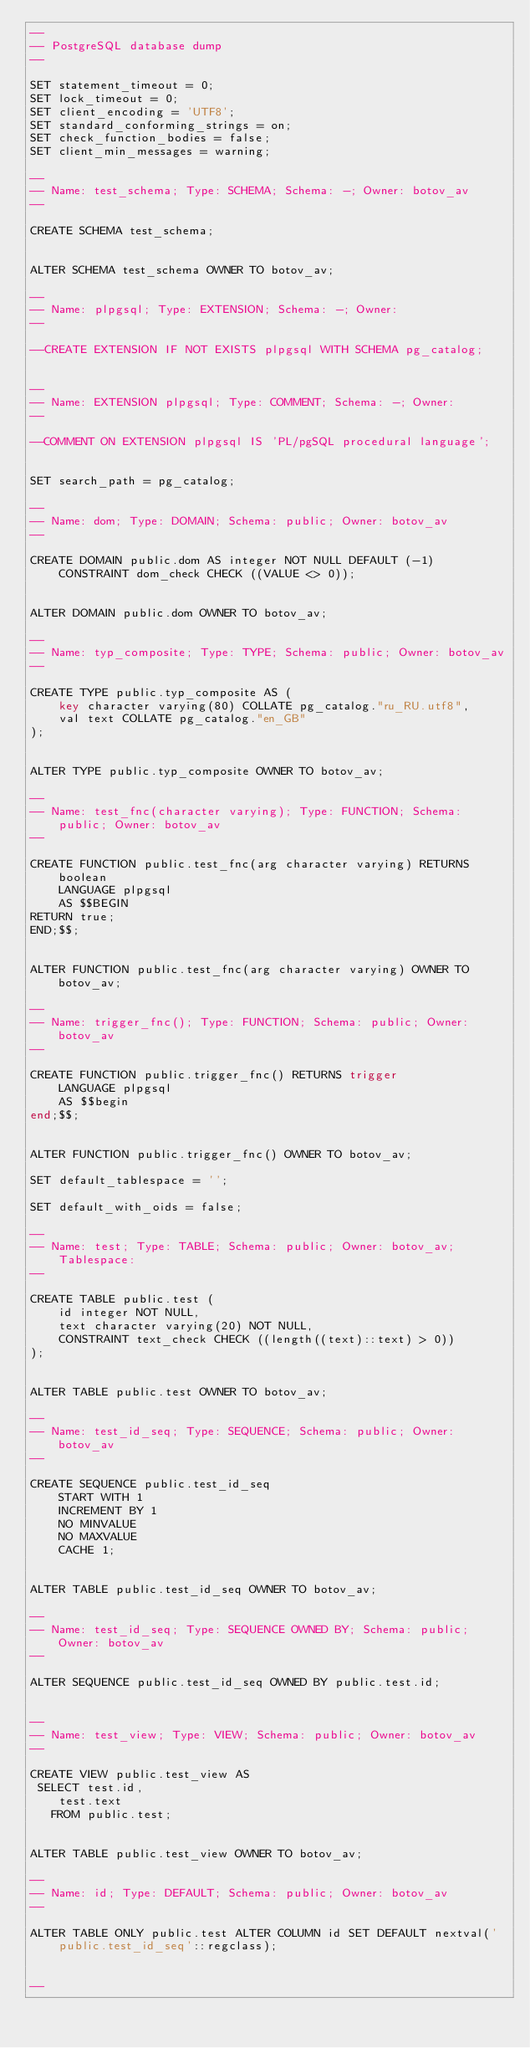Convert code to text. <code><loc_0><loc_0><loc_500><loc_500><_SQL_>--
-- PostgreSQL database dump
--

SET statement_timeout = 0;
SET lock_timeout = 0;
SET client_encoding = 'UTF8';
SET standard_conforming_strings = on;
SET check_function_bodies = false;
SET client_min_messages = warning;

--
-- Name: test_schema; Type: SCHEMA; Schema: -; Owner: botov_av
--

CREATE SCHEMA test_schema;


ALTER SCHEMA test_schema OWNER TO botov_av;

--
-- Name: plpgsql; Type: EXTENSION; Schema: -; Owner: 
--

--CREATE EXTENSION IF NOT EXISTS plpgsql WITH SCHEMA pg_catalog;


--
-- Name: EXTENSION plpgsql; Type: COMMENT; Schema: -; Owner: 
--

--COMMENT ON EXTENSION plpgsql IS 'PL/pgSQL procedural language';


SET search_path = pg_catalog;

--
-- Name: dom; Type: DOMAIN; Schema: public; Owner: botov_av
--

CREATE DOMAIN public.dom AS integer NOT NULL DEFAULT (-1)
	CONSTRAINT dom_check CHECK ((VALUE <> 0));


ALTER DOMAIN public.dom OWNER TO botov_av;

--
-- Name: typ_composite; Type: TYPE; Schema: public; Owner: botov_av
--

CREATE TYPE public.typ_composite AS (
	key character varying(80) COLLATE pg_catalog."ru_RU.utf8",
	val text COLLATE pg_catalog."en_GB"
);


ALTER TYPE public.typ_composite OWNER TO botov_av;

--
-- Name: test_fnc(character varying); Type: FUNCTION; Schema: public; Owner: botov_av
--

CREATE FUNCTION public.test_fnc(arg character varying) RETURNS boolean
    LANGUAGE plpgsql
    AS $$BEGIN
RETURN true;
END;$$;


ALTER FUNCTION public.test_fnc(arg character varying) OWNER TO botov_av;

--
-- Name: trigger_fnc(); Type: FUNCTION; Schema: public; Owner: botov_av
--

CREATE FUNCTION public.trigger_fnc() RETURNS trigger
    LANGUAGE plpgsql
    AS $$begin
end;$$;


ALTER FUNCTION public.trigger_fnc() OWNER TO botov_av;

SET default_tablespace = '';

SET default_with_oids = false;

--
-- Name: test; Type: TABLE; Schema: public; Owner: botov_av; Tablespace: 
--

CREATE TABLE public.test (
    id integer NOT NULL,
    text character varying(20) NOT NULL,
    CONSTRAINT text_check CHECK ((length((text)::text) > 0))
);


ALTER TABLE public.test OWNER TO botov_av;

--
-- Name: test_id_seq; Type: SEQUENCE; Schema: public; Owner: botov_av
--

CREATE SEQUENCE public.test_id_seq
    START WITH 1
    INCREMENT BY 1
    NO MINVALUE
    NO MAXVALUE
    CACHE 1;


ALTER TABLE public.test_id_seq OWNER TO botov_av;

--
-- Name: test_id_seq; Type: SEQUENCE OWNED BY; Schema: public; Owner: botov_av
--

ALTER SEQUENCE public.test_id_seq OWNED BY public.test.id;


--
-- Name: test_view; Type: VIEW; Schema: public; Owner: botov_av
--

CREATE VIEW public.test_view AS
 SELECT test.id,
    test.text
   FROM public.test;


ALTER TABLE public.test_view OWNER TO botov_av;

--
-- Name: id; Type: DEFAULT; Schema: public; Owner: botov_av
--

ALTER TABLE ONLY public.test ALTER COLUMN id SET DEFAULT nextval('public.test_id_seq'::regclass);


--</code> 